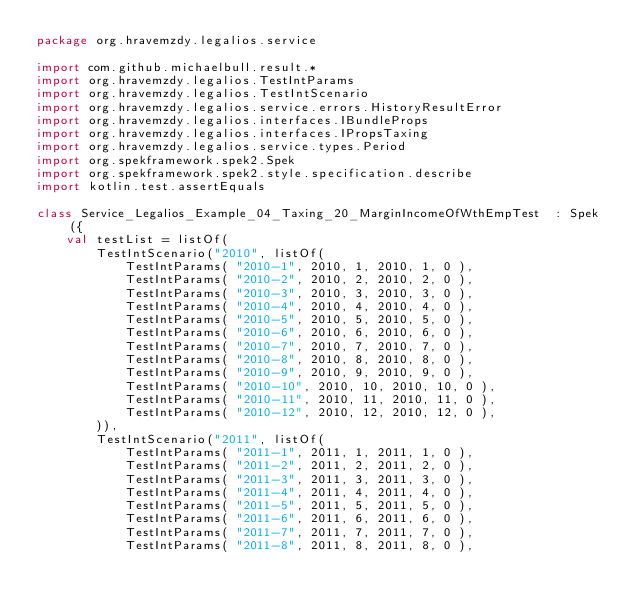<code> <loc_0><loc_0><loc_500><loc_500><_Kotlin_>package org.hravemzdy.legalios.service

import com.github.michaelbull.result.*
import org.hravemzdy.legalios.TestIntParams
import org.hravemzdy.legalios.TestIntScenario
import org.hravemzdy.legalios.service.errors.HistoryResultError
import org.hravemzdy.legalios.interfaces.IBundleProps
import org.hravemzdy.legalios.interfaces.IPropsTaxing
import org.hravemzdy.legalios.service.types.Period
import org.spekframework.spek2.Spek
import org.spekframework.spek2.style.specification.describe
import kotlin.test.assertEquals

class Service_Legalios_Example_04_Taxing_20_MarginIncomeOfWthEmpTest  : Spek({
    val testList = listOf(
        TestIntScenario("2010", listOf(
            TestIntParams( "2010-1", 2010, 1, 2010, 1, 0 ),
            TestIntParams( "2010-2", 2010, 2, 2010, 2, 0 ),
            TestIntParams( "2010-3", 2010, 3, 2010, 3, 0 ),
            TestIntParams( "2010-4", 2010, 4, 2010, 4, 0 ),
            TestIntParams( "2010-5", 2010, 5, 2010, 5, 0 ),
            TestIntParams( "2010-6", 2010, 6, 2010, 6, 0 ),
            TestIntParams( "2010-7", 2010, 7, 2010, 7, 0 ),
            TestIntParams( "2010-8", 2010, 8, 2010, 8, 0 ),
            TestIntParams( "2010-9", 2010, 9, 2010, 9, 0 ),
            TestIntParams( "2010-10", 2010, 10, 2010, 10, 0 ),
            TestIntParams( "2010-11", 2010, 11, 2010, 11, 0 ),
            TestIntParams( "2010-12", 2010, 12, 2010, 12, 0 ),
        )),
        TestIntScenario("2011", listOf(
            TestIntParams( "2011-1", 2011, 1, 2011, 1, 0 ),
            TestIntParams( "2011-2", 2011, 2, 2011, 2, 0 ),
            TestIntParams( "2011-3", 2011, 3, 2011, 3, 0 ),
            TestIntParams( "2011-4", 2011, 4, 2011, 4, 0 ),
            TestIntParams( "2011-5", 2011, 5, 2011, 5, 0 ),
            TestIntParams( "2011-6", 2011, 6, 2011, 6, 0 ),
            TestIntParams( "2011-7", 2011, 7, 2011, 7, 0 ),
            TestIntParams( "2011-8", 2011, 8, 2011, 8, 0 ),</code> 